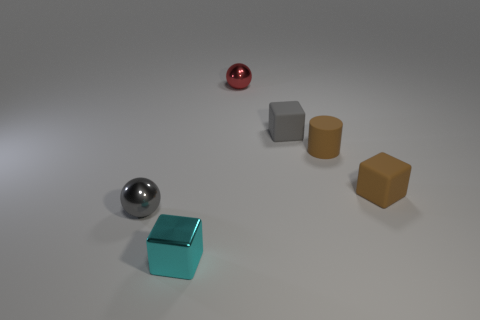The tiny cyan metal object is what shape?
Your answer should be compact. Cube. How many tiny brown matte things have the same shape as the tiny cyan shiny thing?
Keep it short and to the point. 1. How many spheres are tiny brown objects or small things?
Keep it short and to the point. 2. There is a gray thing to the right of the red metal object; is its shape the same as the thing in front of the small gray sphere?
Your answer should be compact. Yes. What is the material of the cyan block?
Give a very brief answer. Metal. The tiny object that is the same color as the matte cylinder is what shape?
Provide a short and direct response. Cube. What number of green rubber spheres are the same size as the cyan cube?
Provide a succinct answer. 0. How many things are either objects in front of the small red metal ball or spheres that are to the left of the tiny cyan metal block?
Keep it short and to the point. 5. Does the tiny brown object that is behind the tiny brown block have the same material as the gray object right of the cyan shiny block?
Your answer should be very brief. Yes. What is the shape of the small brown matte thing in front of the brown object that is to the left of the brown cube?
Keep it short and to the point. Cube. 